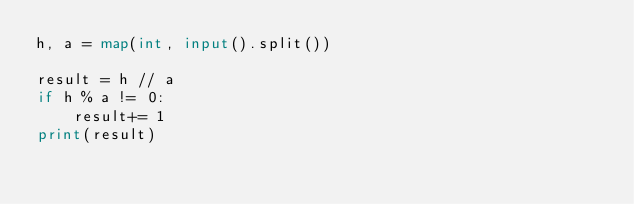Convert code to text. <code><loc_0><loc_0><loc_500><loc_500><_Python_>h, a = map(int, input().split())

result = h // a
if h % a != 0:
    result+= 1
print(result)
</code> 